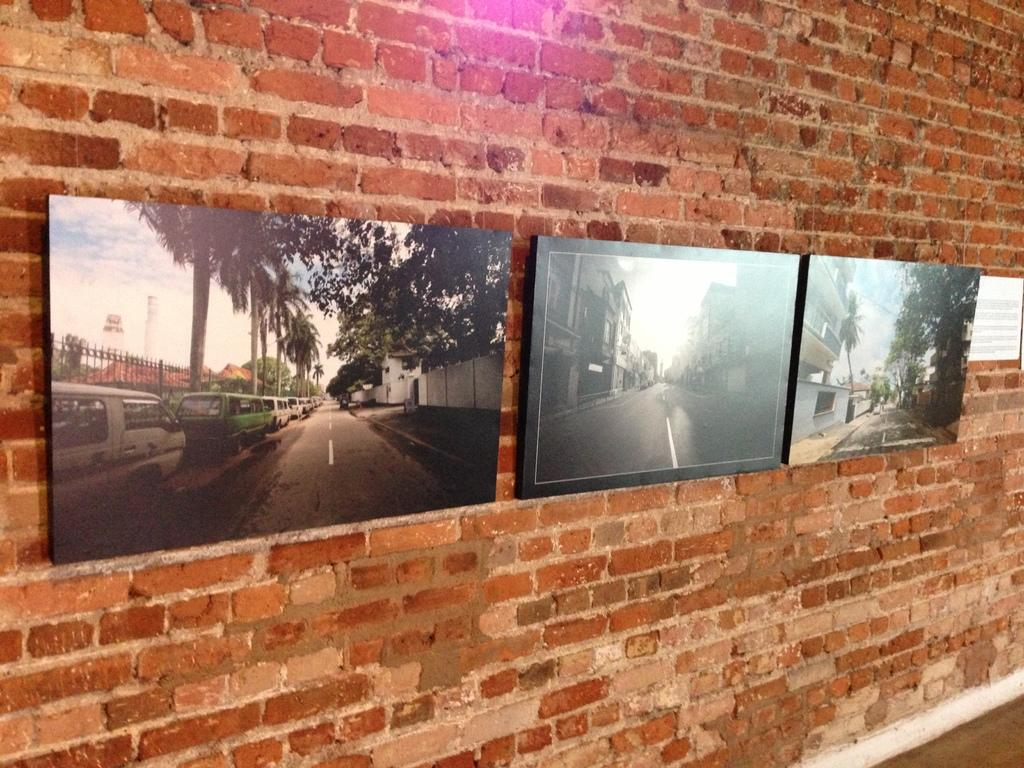What is attached to the wall in the image? There are TV screens on the wall in the image. What is the wall made of? The wall is made up of red bricks. Can you see a cow in the image? No, there is no cow present in the image. Is there a baby in the image? No, there is no baby present in the image. 